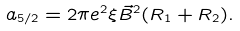<formula> <loc_0><loc_0><loc_500><loc_500>a _ { 5 / 2 } = 2 \pi e ^ { 2 } \xi \vec { B } ^ { 2 } ( R _ { 1 } + R _ { 2 } ) .</formula> 